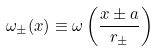<formula> <loc_0><loc_0><loc_500><loc_500>\omega _ { \pm } ( { x } ) \equiv \omega \left ( \frac { { x } \pm { a } } { r _ { \pm } } \right )</formula> 